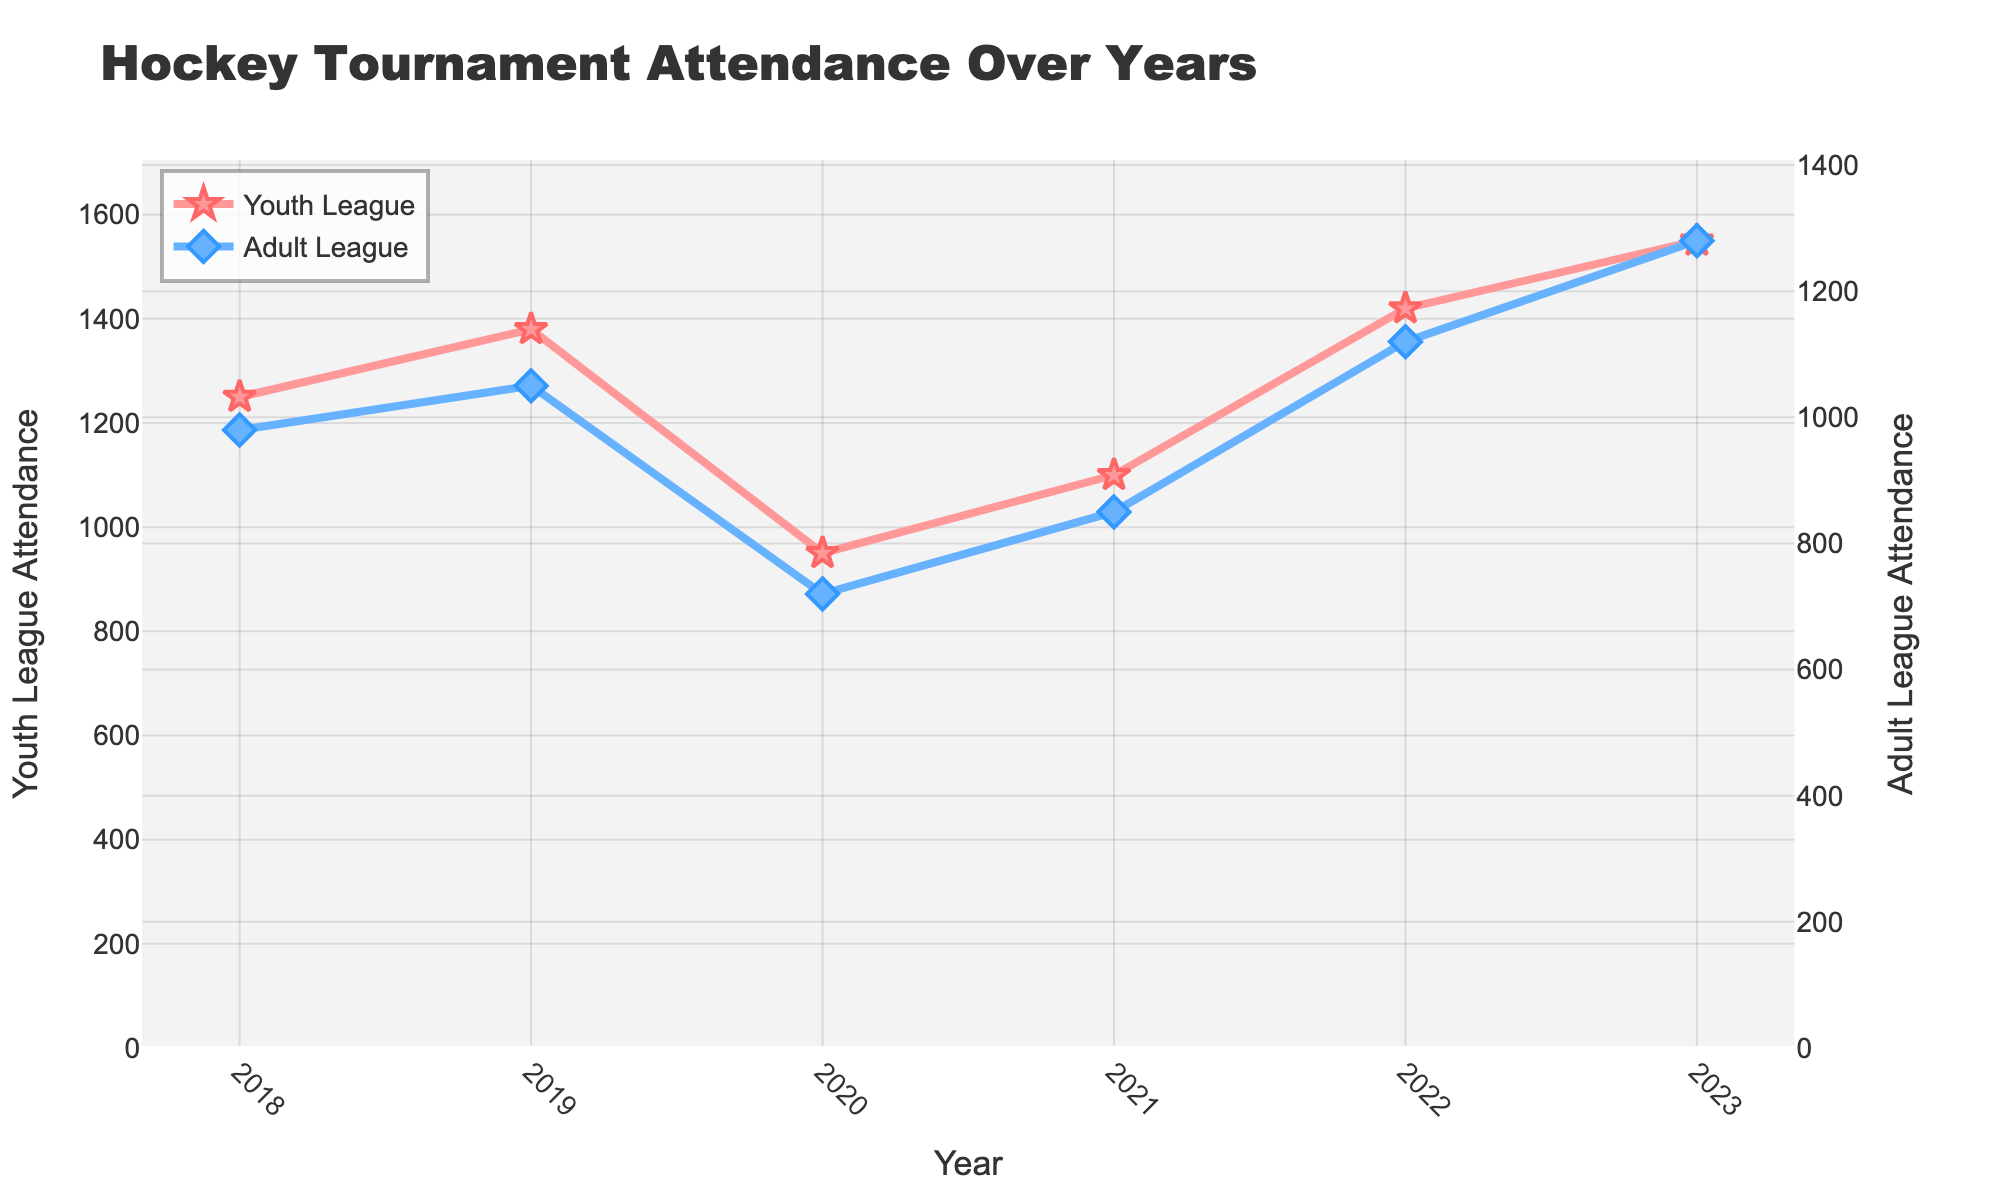What trend can be observed in youth league attendance over the years? Observing the line representing youth league attendance, it shows an overall increasing trend from 2018 to 2023 despite a drop in 2020.
Answer: Increasing trend What was the adult league attendance in 2020? Referring to the data points on the chart, the adult league attendance was 720 in the year 2020.
Answer: 720 How does the youth league attendance in 2023 compare to 2020? Youth league attendance in 2023 is 1550, whereas it was 950 in 2020. 1550 is greater than 950 by 600 attendees.
Answer: 600 higher In which year did both leagues experience an increase in attendance compared to the previous year? By comparing each year's data points, both leagues saw an increase in 2022 compared to 2021. Youth league attendance increased from 1100 to 1420, and adult league attendance increased from 850 to 1120.
Answer: 2022 What was the difference in attendance between the youth and adult leagues in 2023? Youth league attendance in 2023 was 1550, while adult league attendance was 1280. The difference is 1550 - 1280 = 270.
Answer: 270 What is the average attendance for the adult league over the 6 years? Sum of adult league attendance over the years = 980 + 1050 + 720 + 850 + 1120 + 1280 = 6000. Average = 6000 / 6 = 1000.
Answer: 1000 Which league saw a more significant increase in attendance from 2021 to 2022? Youth league attendance increased from 1100 to 1420 (320 attendees) and adult league from 850 to 1120 (270 attendees). The youth league had a more significant increase.
Answer: Youth league In which year did youth league attendance surpass 1500? Observing the line chart, youth league attendance surpassed 1500 in the year 2023.
Answer: 2023 Which league has more variable attendance overall? Comparing the fluctuations in both lines, the youth league shows more variability, especially with a larger dip in 2020 and higher peaks.
Answer: Youth league 